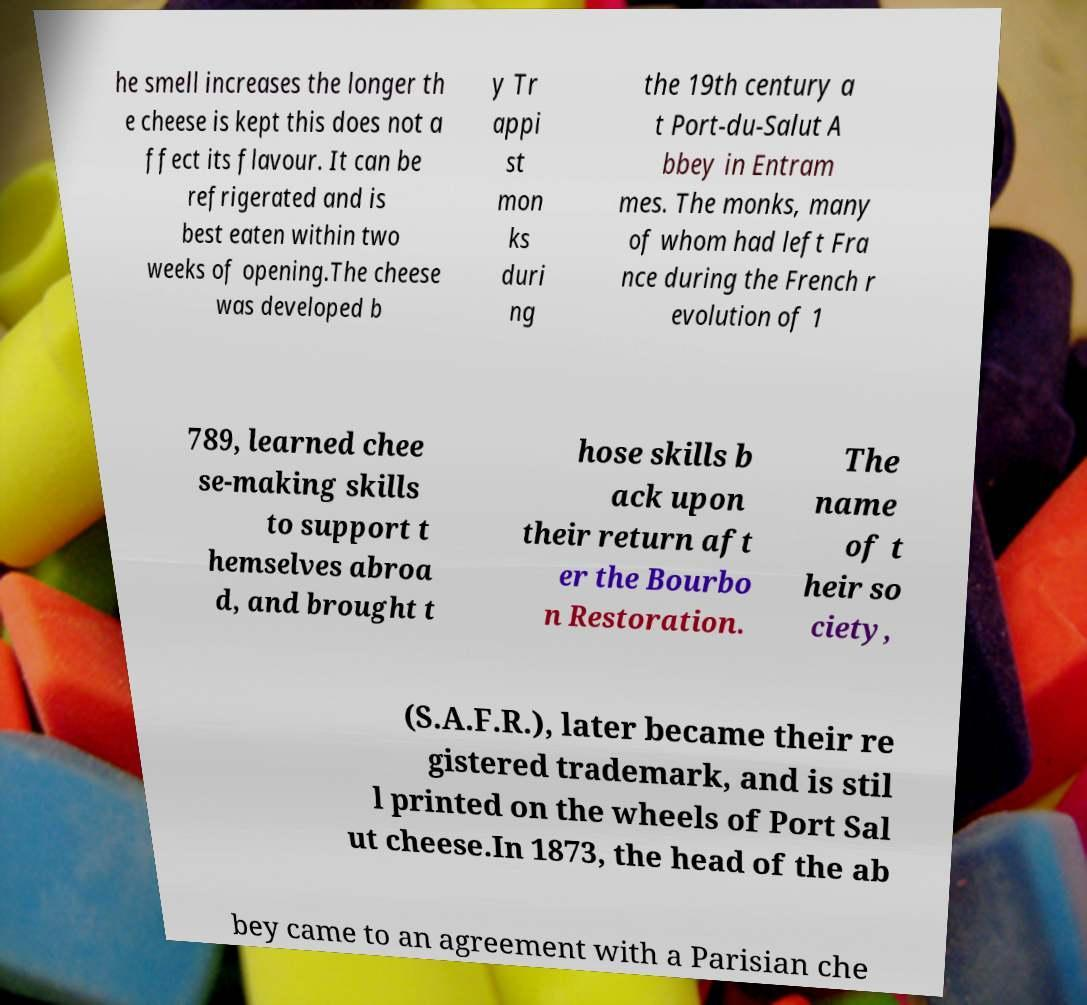For documentation purposes, I need the text within this image transcribed. Could you provide that? he smell increases the longer th e cheese is kept this does not a ffect its flavour. It can be refrigerated and is best eaten within two weeks of opening.The cheese was developed b y Tr appi st mon ks duri ng the 19th century a t Port-du-Salut A bbey in Entram mes. The monks, many of whom had left Fra nce during the French r evolution of 1 789, learned chee se-making skills to support t hemselves abroa d, and brought t hose skills b ack upon their return aft er the Bourbo n Restoration. The name of t heir so ciety, (S.A.F.R.), later became their re gistered trademark, and is stil l printed on the wheels of Port Sal ut cheese.In 1873, the head of the ab bey came to an agreement with a Parisian che 